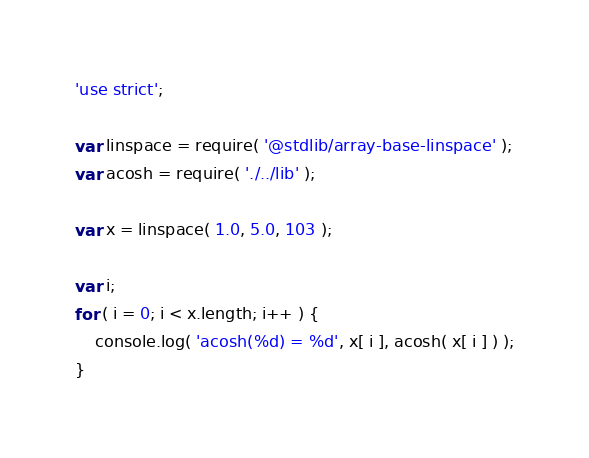<code> <loc_0><loc_0><loc_500><loc_500><_JavaScript_>'use strict';

var linspace = require( '@stdlib/array-base-linspace' );
var acosh = require( './../lib' );

var x = linspace( 1.0, 5.0, 103 );

var i;
for ( i = 0; i < x.length; i++ ) {
	console.log( 'acosh(%d) = %d', x[ i ], acosh( x[ i ] ) );
}
</code> 